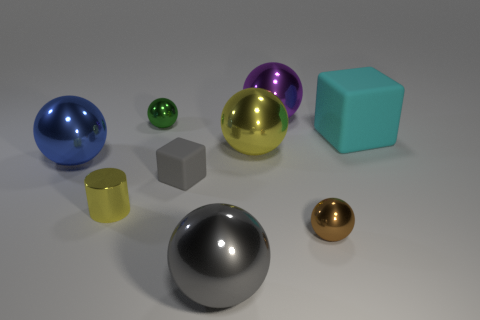The rubber cube that is to the right of the block on the left side of the matte thing on the right side of the purple metal sphere is what color?
Offer a very short reply. Cyan. What shape is the green thing that is the same size as the brown object?
Make the answer very short. Sphere. Is there anything else that has the same size as the blue metallic object?
Your answer should be compact. Yes. There is a rubber object to the right of the tiny gray cube; does it have the same size as the gray object that is in front of the small gray cube?
Your answer should be compact. Yes. What size is the yellow shiny thing on the left side of the tiny gray cube?
Your response must be concise. Small. There is a large ball that is the same color as the small shiny cylinder; what material is it?
Offer a very short reply. Metal. There is another ball that is the same size as the brown metallic ball; what color is it?
Keep it short and to the point. Green. Is the purple object the same size as the gray matte thing?
Your answer should be very brief. No. There is a metallic object that is on the right side of the green sphere and left of the yellow sphere; how big is it?
Make the answer very short. Large. What number of metallic objects are green objects or brown balls?
Provide a short and direct response. 2. 